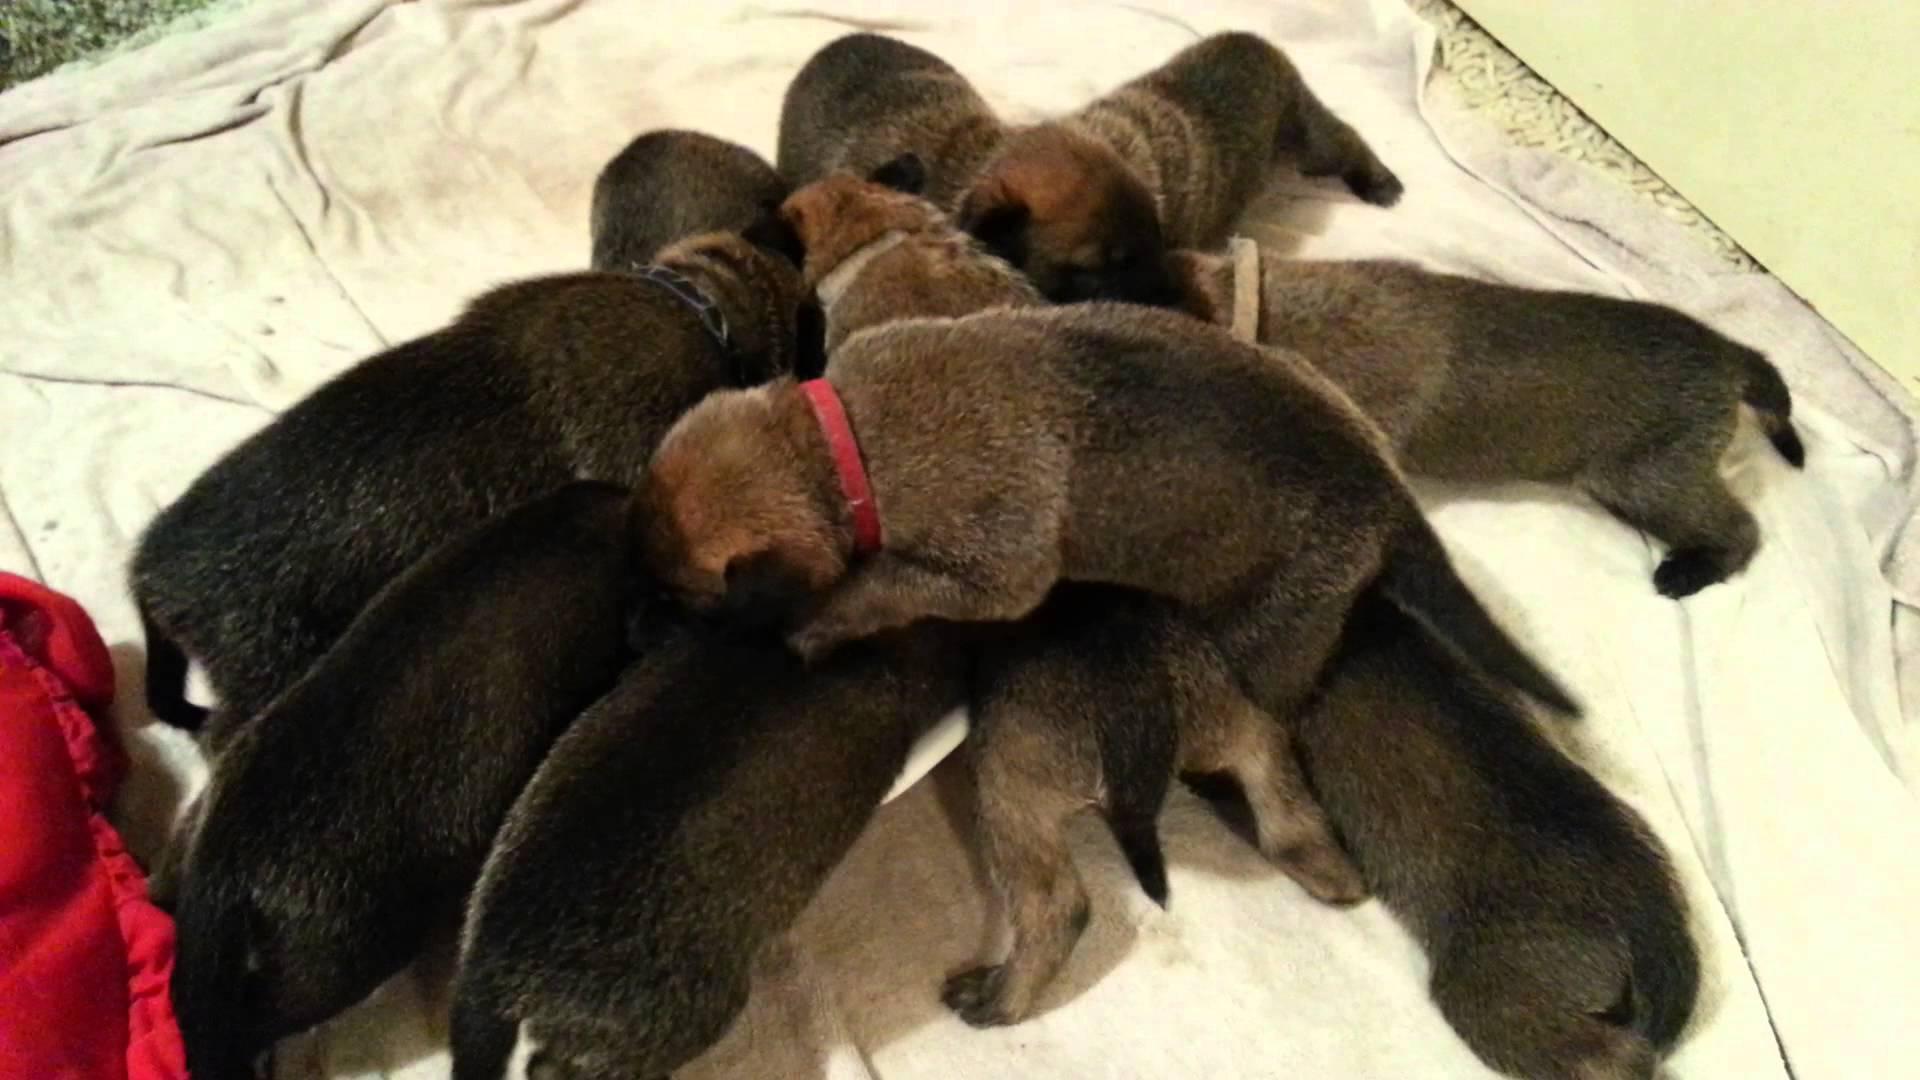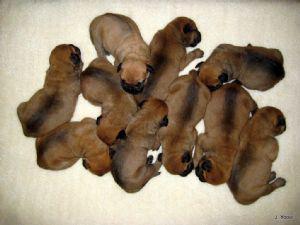The first image is the image on the left, the second image is the image on the right. Assess this claim about the two images: "An image shows puppies in collars on a blanket, with their heads aimed toward the middle of the group.". Correct or not? Answer yes or no. Yes. The first image is the image on the left, the second image is the image on the right. Analyze the images presented: Is the assertion "There's no more than five dogs in the right image." valid? Answer yes or no. No. 